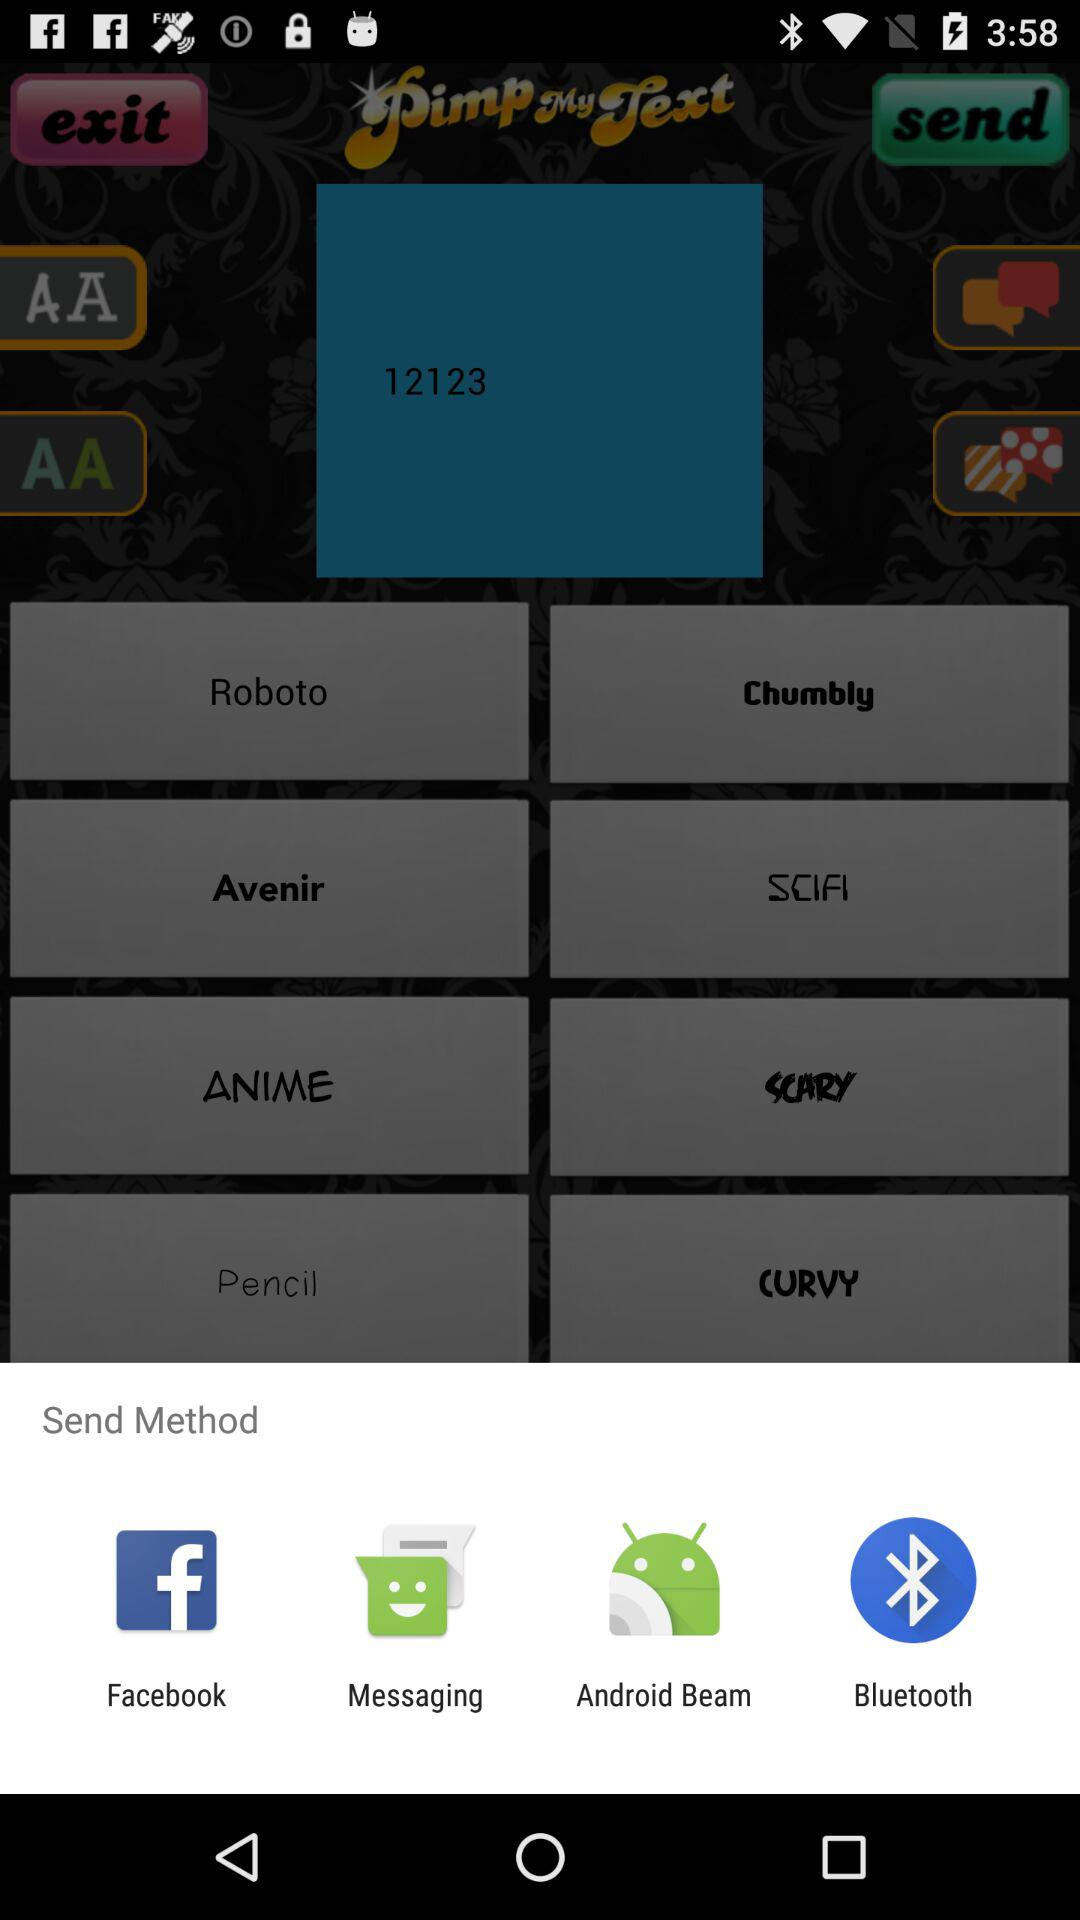What are the options for sending the content? The options for sending the content are "Facebook", "Messaging", "Android Beam" and "Bluetooth". 